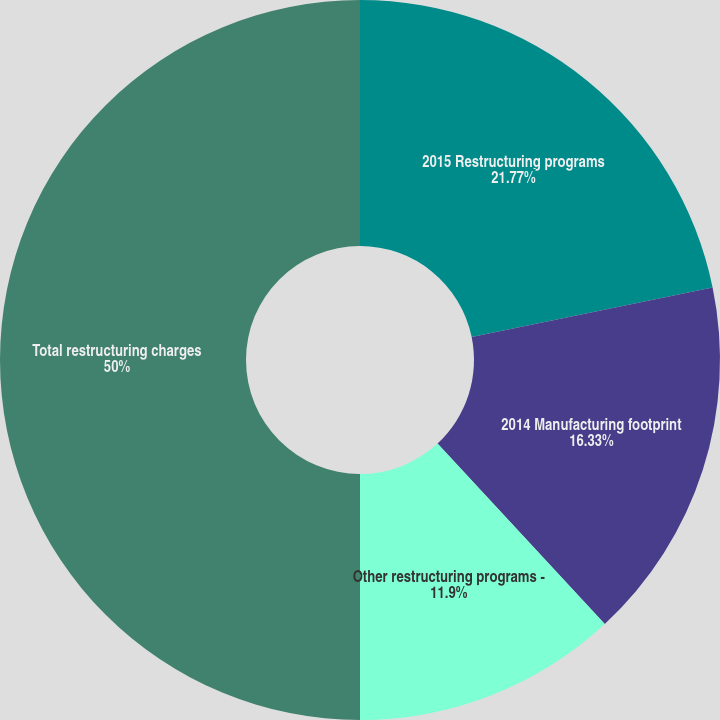Convert chart to OTSL. <chart><loc_0><loc_0><loc_500><loc_500><pie_chart><fcel>2015 Restructuring programs<fcel>2014 Manufacturing footprint<fcel>Other restructuring programs -<fcel>Total restructuring charges<nl><fcel>21.77%<fcel>16.33%<fcel>11.9%<fcel>50.0%<nl></chart> 